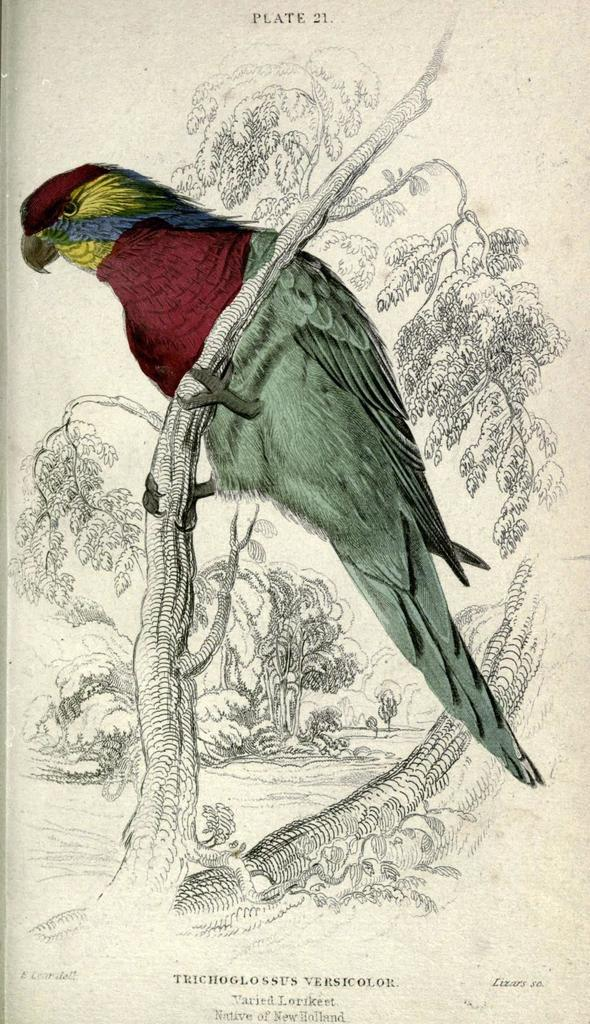What type of animal is in the image? There is a bird in the image. Where is the bird located? The bird is on a branch. What colors can be seen on the bird? The bird has maroon, green, green, and yellow colors. What colors are used in the background of the image? The background of the image is in white and black colors. What type of star can be seen in the oven in the image? There is no star or oven present in the image; it features a bird on a branch with a white and black background. 